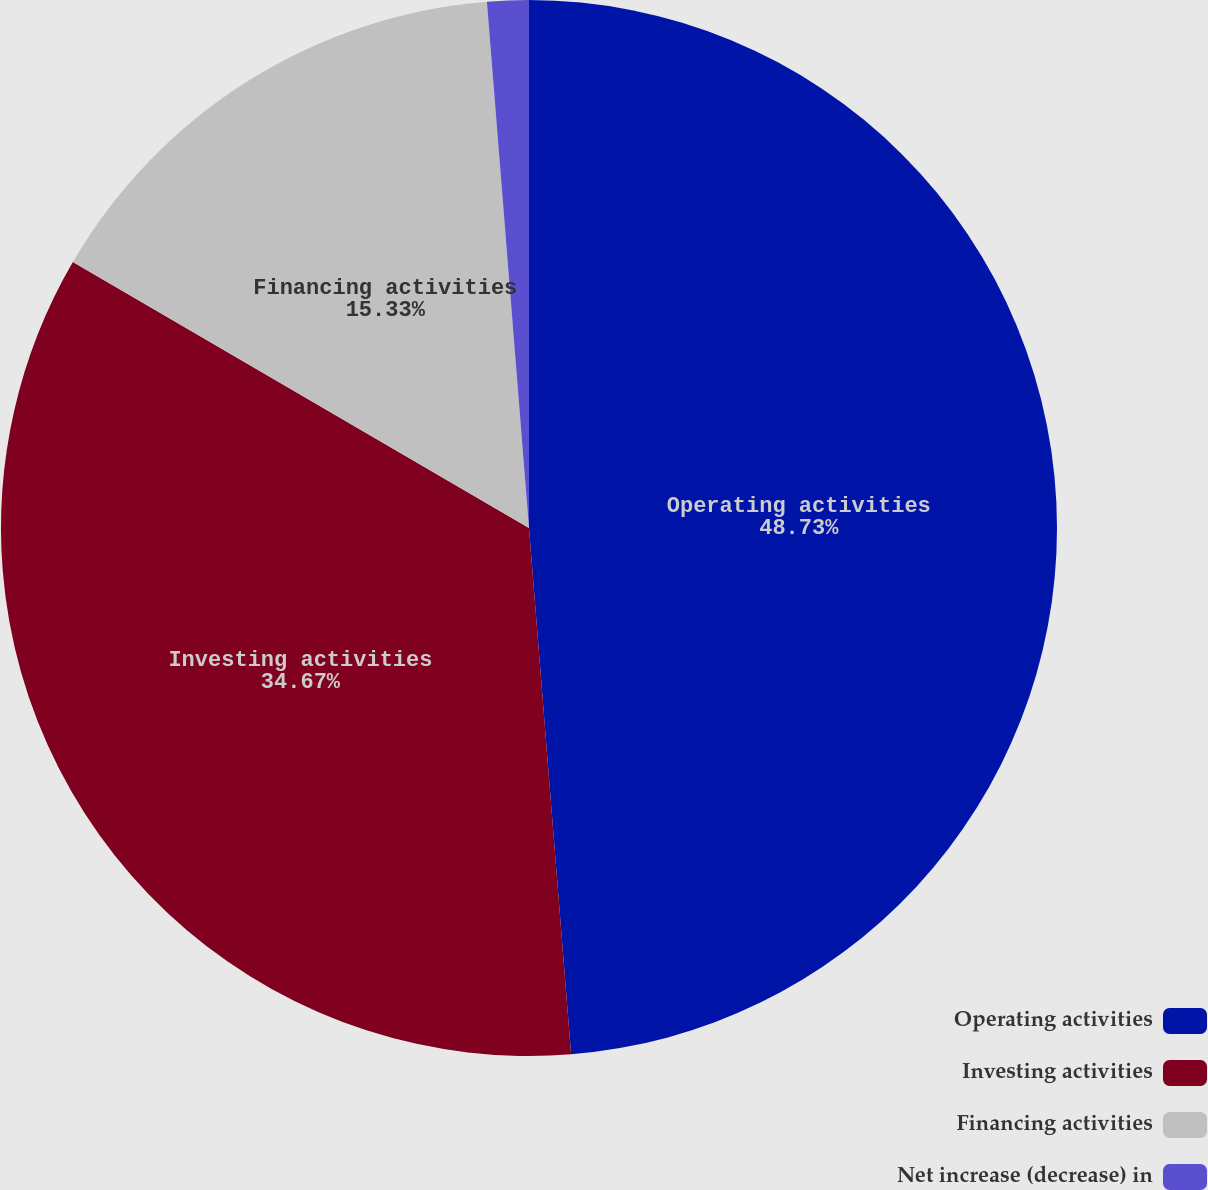<chart> <loc_0><loc_0><loc_500><loc_500><pie_chart><fcel>Operating activities<fcel>Investing activities<fcel>Financing activities<fcel>Net increase (decrease) in<nl><fcel>48.73%<fcel>34.67%<fcel>15.33%<fcel>1.27%<nl></chart> 